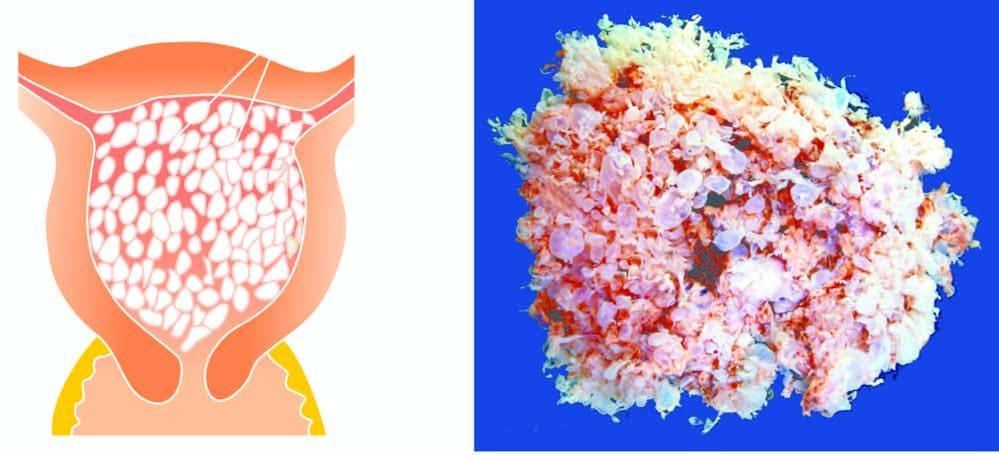what are also seen?
Answer the question using a single word or phrase. Tan areas of haemorrhage 